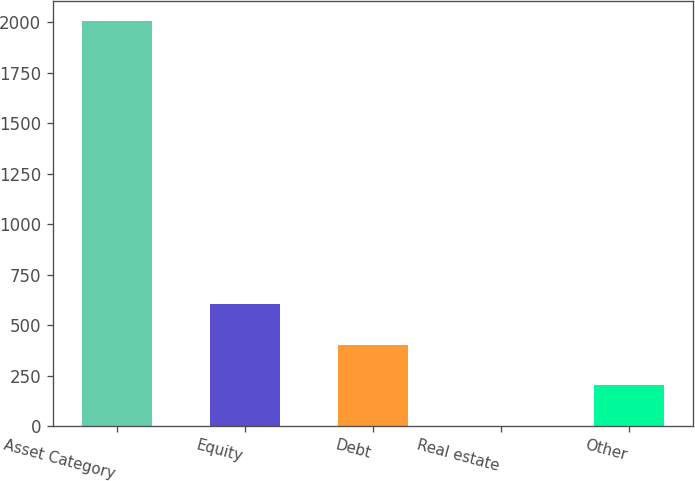Convert chart. <chart><loc_0><loc_0><loc_500><loc_500><bar_chart><fcel>Asset Category<fcel>Equity<fcel>Debt<fcel>Real estate<fcel>Other<nl><fcel>2004<fcel>603.3<fcel>403.2<fcel>3<fcel>203.1<nl></chart> 